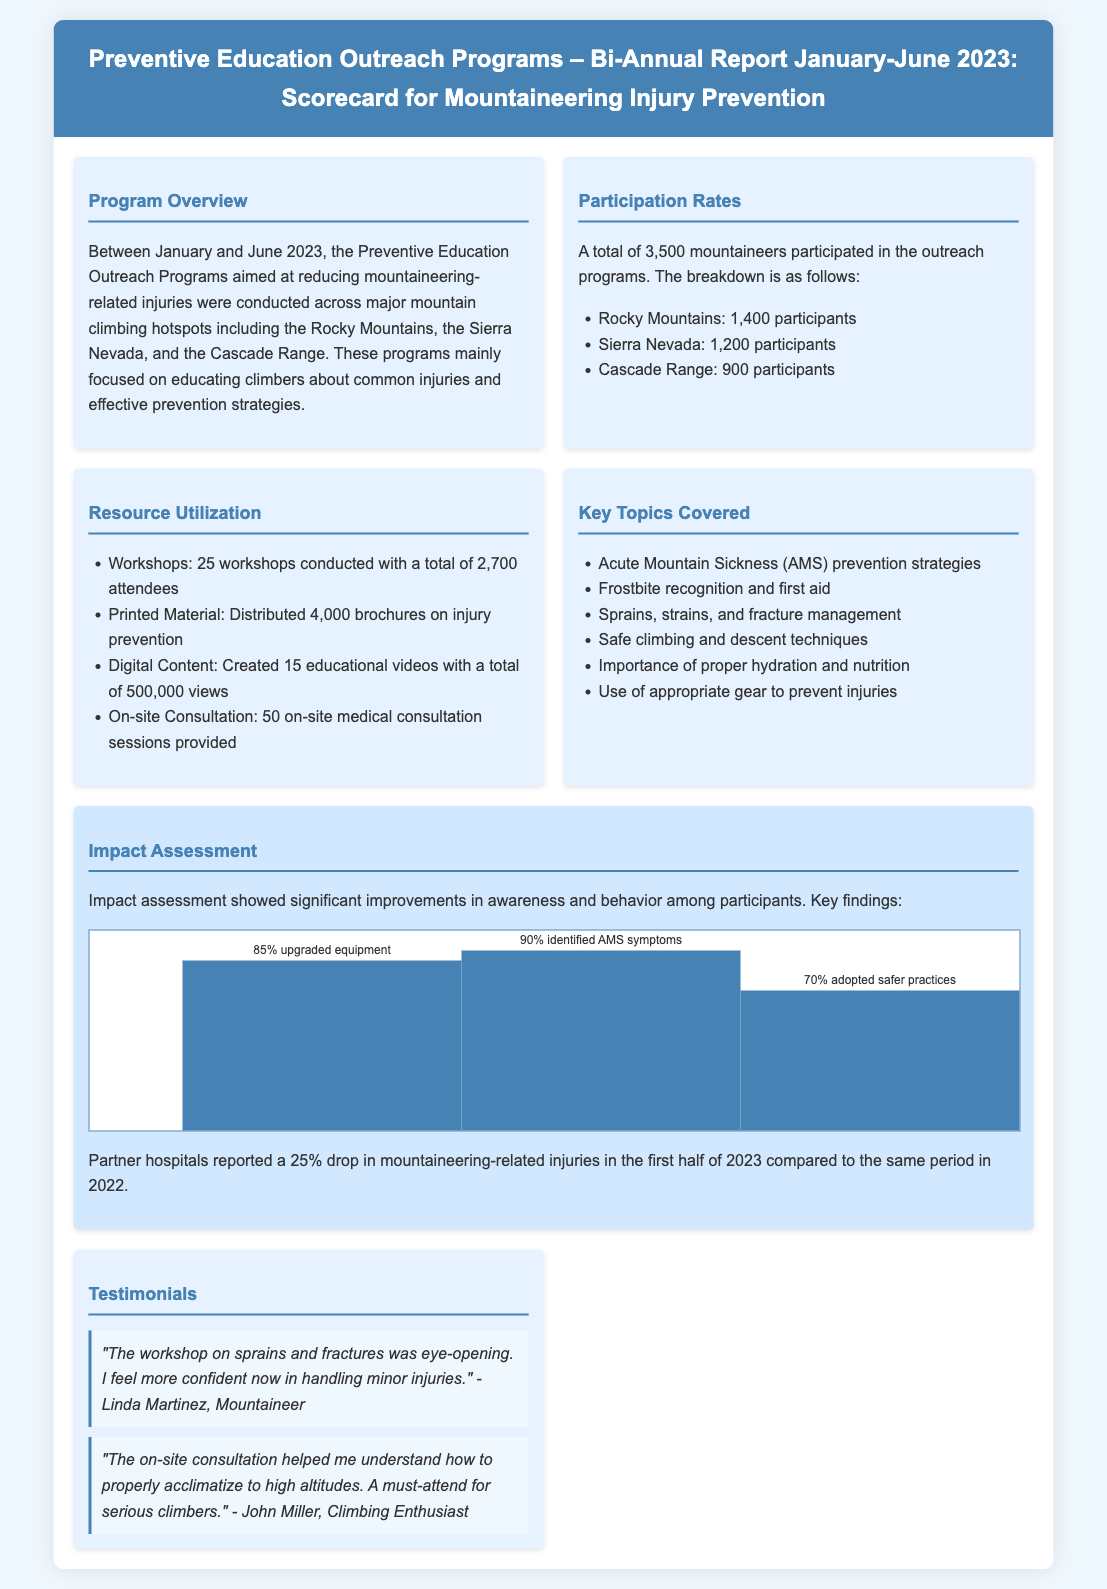What was the total number of mountaineers who participated? The total participation was reported as 3,500 mountaineers across various programs.
Answer: 3,500 How many workshops were conducted? The document states that 25 workshops were conducted during this period.
Answer: 25 What percentage of participants upgraded their equipment? The impact assessment indicated that 85% of participants upgraded their equipment.
Answer: 85% Which region had the highest participation? According to the breakdown, the Rocky Mountains had 1,400 participants, the highest among the regions.
Answer: Rocky Mountains What was the reported drop in mountaineering-related injuries? Partner hospitals reported a 25% drop in injuries during the first half of 2023 compared to 2022.
Answer: 25% How many educational videos were created? The outreach program created 15 educational videos as part of the resources.
Answer: 15 What key topic related to acclimatization was covered? The document mentions "AMS prevention strategies" as a key topic covered in the workshops.
Answer: AMS prevention strategies What is the total number of brochures distributed? The report states that 4,000 brochures on injury prevention were distributed.
Answer: 4,000 How many participants identified AMS symptoms? The impact assessment showed that 90% of participants identified AMS symptoms.
Answer: 90% 